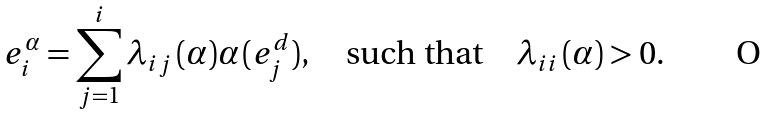Convert formula to latex. <formula><loc_0><loc_0><loc_500><loc_500>e _ { i } ^ { \alpha } = \sum _ { j = 1 } ^ { i } \lambda _ { i j } \, ( \alpha ) \alpha \, ( e _ { j } ^ { d } ) , \quad \text {such that} \quad \lambda _ { i i } \, ( \alpha ) > 0 .</formula> 